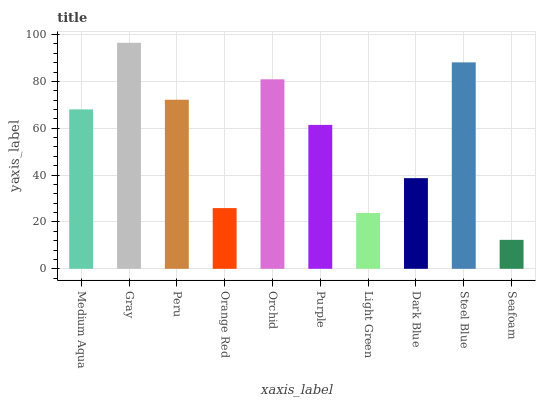Is Seafoam the minimum?
Answer yes or no. Yes. Is Gray the maximum?
Answer yes or no. Yes. Is Peru the minimum?
Answer yes or no. No. Is Peru the maximum?
Answer yes or no. No. Is Gray greater than Peru?
Answer yes or no. Yes. Is Peru less than Gray?
Answer yes or no. Yes. Is Peru greater than Gray?
Answer yes or no. No. Is Gray less than Peru?
Answer yes or no. No. Is Medium Aqua the high median?
Answer yes or no. Yes. Is Purple the low median?
Answer yes or no. Yes. Is Orange Red the high median?
Answer yes or no. No. Is Orange Red the low median?
Answer yes or no. No. 